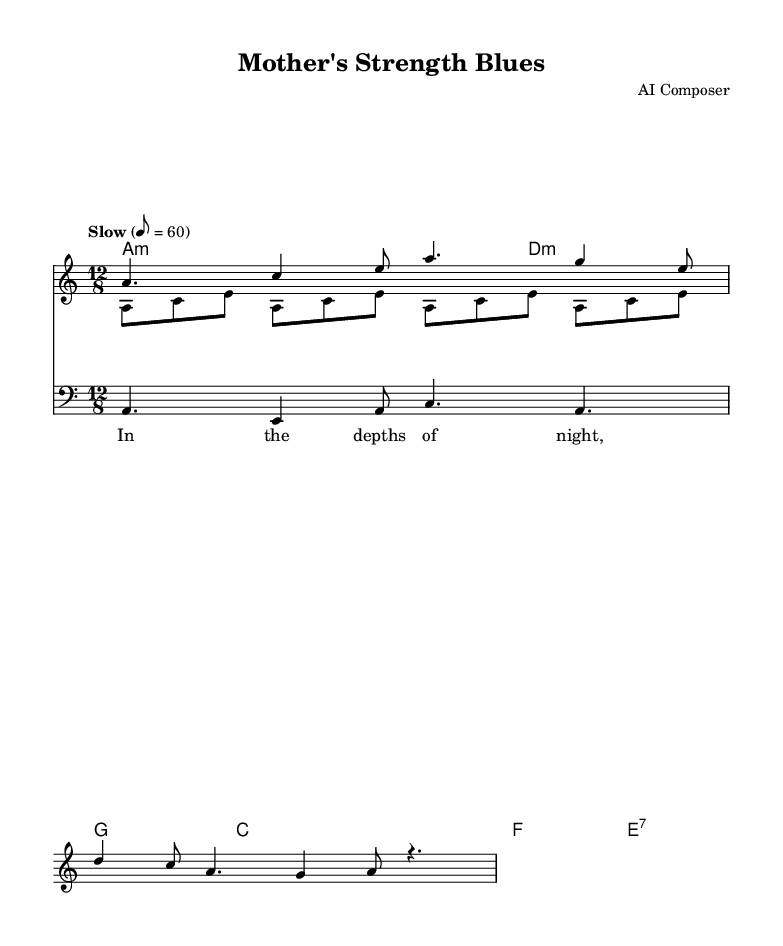What is the key signature of this music? The key signature is A minor, which is indicated by the absence of sharps or flats. The corresponding scale notes confirm this key signature.
Answer: A minor What is the time signature of this music? The time signature is 12/8, shown at the beginning of the score. This indicates there are 12 eighth notes in each measure, organized into four groups of three.
Answer: 12/8 What is the tempo marking for this piece? The tempo marking states "Slow" with a metronome marking of 8 = 60, indicating the pace at which the music should be played, specifically indicating beats per minute.
Answer: Slow How many measures are in the melody section? The melody section consists of 4 measures, as indicated by the notation shown, with each section separated by vertical bar lines.
Answer: 4 What type of scale is primarily used in this piece's melody? The melody primarily utilizes the A minor scale, which can be identified by the notes flowing within the range of that scale, reflecting the A minor tonality throughout.
Answer: A minor What is the chord progression used in the music? The chord progression consists of A minor, D minor, G, C, and F chords, which are indicated in the chord names section and follow the typical structure of a blues progression.
Answer: A minor, D minor, G, C, F What lyrical theme is portrayed in the lyrics? The lyrics portray the theme of maternal strength and love, highlighted by phrases like “mother's love, so strong and deep,” which encapsulates the emotional resonance of motherhood.
Answer: Maternal strength and love 